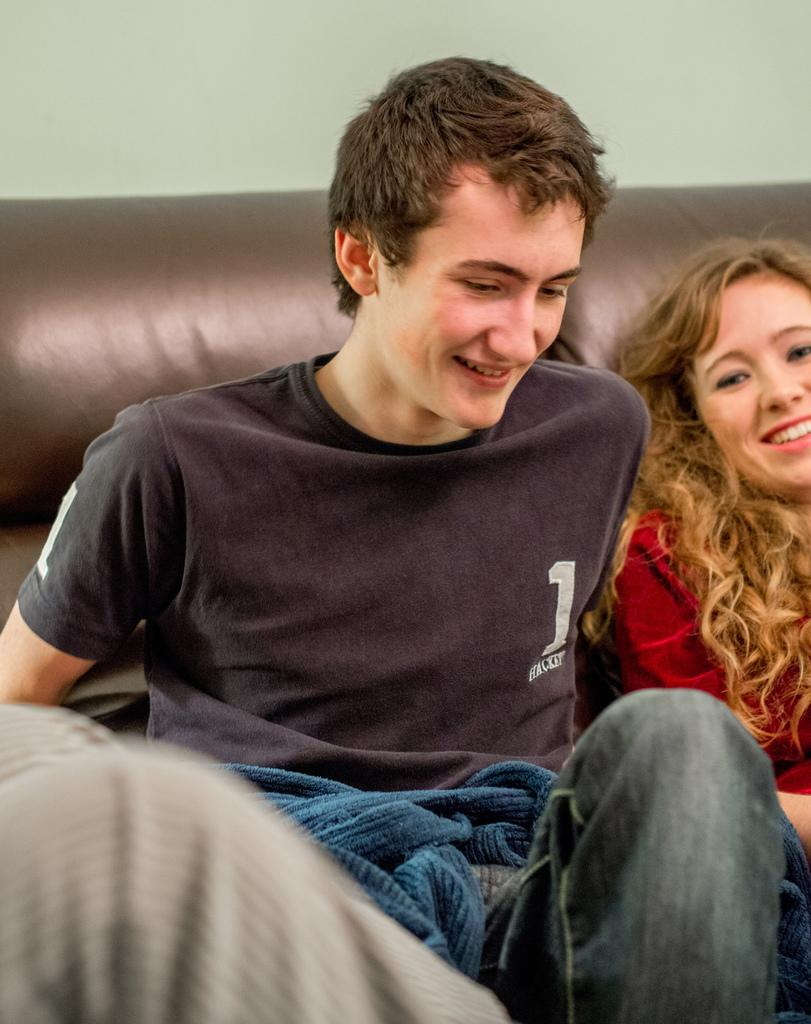How many people are in the image? There are two people in the image. What are the people doing in the image? The people are sitting on a couch. What is in front of the man in the image? There are clothes in front of the man. What is visible behind the people in the image? There is a wall behind the people. Can you see any steam coming from the toad in the image? There is no toad present in the image, and therefore no steam can be seen. 